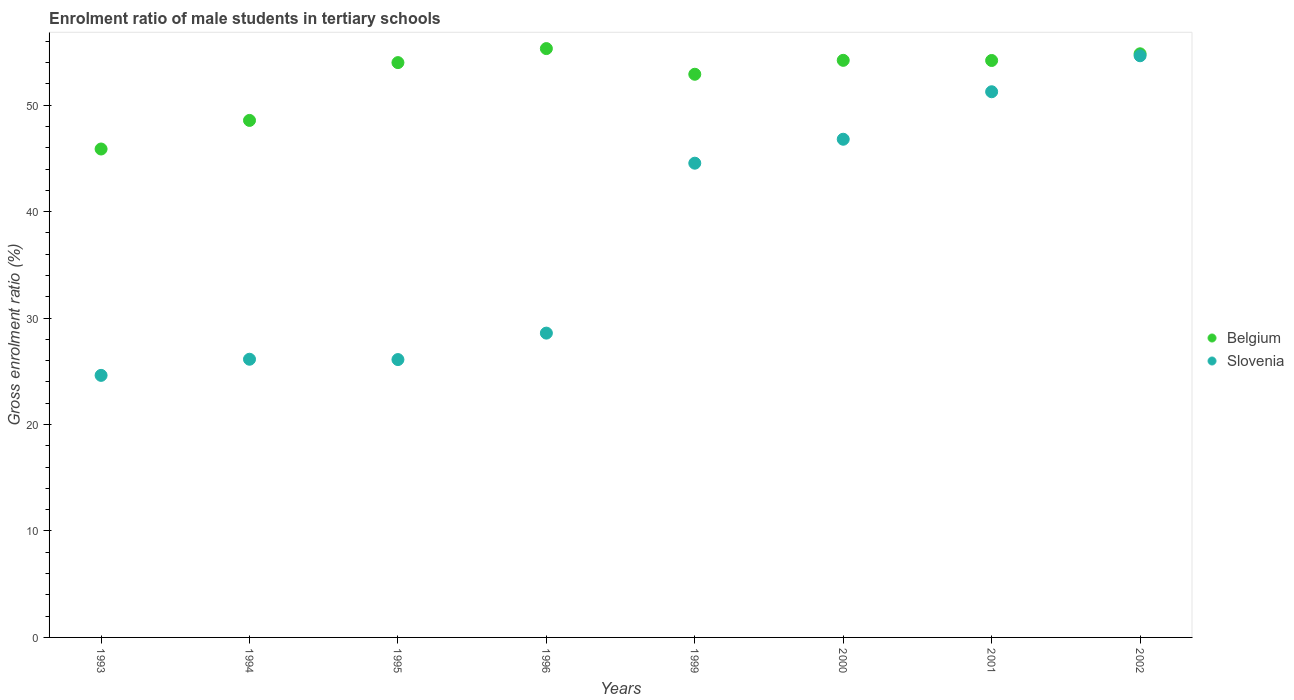Is the number of dotlines equal to the number of legend labels?
Offer a very short reply. Yes. What is the enrolment ratio of male students in tertiary schools in Slovenia in 2002?
Your answer should be compact. 54.65. Across all years, what is the maximum enrolment ratio of male students in tertiary schools in Belgium?
Ensure brevity in your answer.  55.33. Across all years, what is the minimum enrolment ratio of male students in tertiary schools in Belgium?
Offer a terse response. 45.89. What is the total enrolment ratio of male students in tertiary schools in Belgium in the graph?
Provide a short and direct response. 419.98. What is the difference between the enrolment ratio of male students in tertiary schools in Slovenia in 1994 and that in 2000?
Ensure brevity in your answer.  -20.67. What is the difference between the enrolment ratio of male students in tertiary schools in Belgium in 1994 and the enrolment ratio of male students in tertiary schools in Slovenia in 1999?
Make the answer very short. 4.02. What is the average enrolment ratio of male students in tertiary schools in Belgium per year?
Offer a very short reply. 52.5. In the year 1993, what is the difference between the enrolment ratio of male students in tertiary schools in Slovenia and enrolment ratio of male students in tertiary schools in Belgium?
Provide a succinct answer. -21.27. What is the ratio of the enrolment ratio of male students in tertiary schools in Belgium in 1996 to that in 2002?
Ensure brevity in your answer.  1.01. What is the difference between the highest and the second highest enrolment ratio of male students in tertiary schools in Belgium?
Make the answer very short. 0.49. What is the difference between the highest and the lowest enrolment ratio of male students in tertiary schools in Belgium?
Your answer should be compact. 9.44. In how many years, is the enrolment ratio of male students in tertiary schools in Belgium greater than the average enrolment ratio of male students in tertiary schools in Belgium taken over all years?
Offer a terse response. 6. Is the sum of the enrolment ratio of male students in tertiary schools in Slovenia in 1993 and 1994 greater than the maximum enrolment ratio of male students in tertiary schools in Belgium across all years?
Your answer should be very brief. No. Does the enrolment ratio of male students in tertiary schools in Slovenia monotonically increase over the years?
Keep it short and to the point. No. Is the enrolment ratio of male students in tertiary schools in Belgium strictly less than the enrolment ratio of male students in tertiary schools in Slovenia over the years?
Your answer should be very brief. No. How many years are there in the graph?
Make the answer very short. 8. What is the difference between two consecutive major ticks on the Y-axis?
Offer a terse response. 10. Does the graph contain grids?
Offer a very short reply. No. What is the title of the graph?
Offer a very short reply. Enrolment ratio of male students in tertiary schools. What is the label or title of the X-axis?
Ensure brevity in your answer.  Years. What is the Gross enrolment ratio (%) of Belgium in 1993?
Your response must be concise. 45.89. What is the Gross enrolment ratio (%) in Slovenia in 1993?
Give a very brief answer. 24.62. What is the Gross enrolment ratio (%) of Belgium in 1994?
Provide a succinct answer. 48.58. What is the Gross enrolment ratio (%) in Slovenia in 1994?
Your answer should be very brief. 26.14. What is the Gross enrolment ratio (%) of Belgium in 1995?
Your answer should be compact. 54.01. What is the Gross enrolment ratio (%) of Slovenia in 1995?
Keep it short and to the point. 26.11. What is the Gross enrolment ratio (%) in Belgium in 1996?
Provide a succinct answer. 55.33. What is the Gross enrolment ratio (%) in Slovenia in 1996?
Offer a terse response. 28.59. What is the Gross enrolment ratio (%) in Belgium in 1999?
Provide a succinct answer. 52.91. What is the Gross enrolment ratio (%) in Slovenia in 1999?
Ensure brevity in your answer.  44.56. What is the Gross enrolment ratio (%) of Belgium in 2000?
Provide a short and direct response. 54.22. What is the Gross enrolment ratio (%) of Slovenia in 2000?
Keep it short and to the point. 46.81. What is the Gross enrolment ratio (%) in Belgium in 2001?
Offer a very short reply. 54.21. What is the Gross enrolment ratio (%) in Slovenia in 2001?
Provide a short and direct response. 51.27. What is the Gross enrolment ratio (%) in Belgium in 2002?
Keep it short and to the point. 54.84. What is the Gross enrolment ratio (%) in Slovenia in 2002?
Provide a short and direct response. 54.65. Across all years, what is the maximum Gross enrolment ratio (%) in Belgium?
Provide a succinct answer. 55.33. Across all years, what is the maximum Gross enrolment ratio (%) in Slovenia?
Offer a very short reply. 54.65. Across all years, what is the minimum Gross enrolment ratio (%) of Belgium?
Offer a very short reply. 45.89. Across all years, what is the minimum Gross enrolment ratio (%) of Slovenia?
Offer a very short reply. 24.62. What is the total Gross enrolment ratio (%) in Belgium in the graph?
Provide a short and direct response. 419.98. What is the total Gross enrolment ratio (%) in Slovenia in the graph?
Provide a short and direct response. 302.75. What is the difference between the Gross enrolment ratio (%) in Belgium in 1993 and that in 1994?
Offer a very short reply. -2.69. What is the difference between the Gross enrolment ratio (%) in Slovenia in 1993 and that in 1994?
Provide a succinct answer. -1.52. What is the difference between the Gross enrolment ratio (%) in Belgium in 1993 and that in 1995?
Provide a succinct answer. -8.12. What is the difference between the Gross enrolment ratio (%) in Slovenia in 1993 and that in 1995?
Provide a short and direct response. -1.49. What is the difference between the Gross enrolment ratio (%) of Belgium in 1993 and that in 1996?
Your answer should be compact. -9.44. What is the difference between the Gross enrolment ratio (%) of Slovenia in 1993 and that in 1996?
Offer a terse response. -3.97. What is the difference between the Gross enrolment ratio (%) in Belgium in 1993 and that in 1999?
Your answer should be very brief. -7.02. What is the difference between the Gross enrolment ratio (%) in Slovenia in 1993 and that in 1999?
Offer a very short reply. -19.94. What is the difference between the Gross enrolment ratio (%) in Belgium in 1993 and that in 2000?
Offer a terse response. -8.33. What is the difference between the Gross enrolment ratio (%) in Slovenia in 1993 and that in 2000?
Ensure brevity in your answer.  -22.19. What is the difference between the Gross enrolment ratio (%) of Belgium in 1993 and that in 2001?
Provide a succinct answer. -8.32. What is the difference between the Gross enrolment ratio (%) of Slovenia in 1993 and that in 2001?
Your answer should be compact. -26.65. What is the difference between the Gross enrolment ratio (%) of Belgium in 1993 and that in 2002?
Give a very brief answer. -8.95. What is the difference between the Gross enrolment ratio (%) in Slovenia in 1993 and that in 2002?
Offer a very short reply. -30.03. What is the difference between the Gross enrolment ratio (%) of Belgium in 1994 and that in 1995?
Make the answer very short. -5.43. What is the difference between the Gross enrolment ratio (%) in Slovenia in 1994 and that in 1995?
Keep it short and to the point. 0.03. What is the difference between the Gross enrolment ratio (%) in Belgium in 1994 and that in 1996?
Offer a terse response. -6.75. What is the difference between the Gross enrolment ratio (%) in Slovenia in 1994 and that in 1996?
Your answer should be compact. -2.45. What is the difference between the Gross enrolment ratio (%) in Belgium in 1994 and that in 1999?
Give a very brief answer. -4.34. What is the difference between the Gross enrolment ratio (%) in Slovenia in 1994 and that in 1999?
Provide a short and direct response. -18.42. What is the difference between the Gross enrolment ratio (%) of Belgium in 1994 and that in 2000?
Your answer should be compact. -5.64. What is the difference between the Gross enrolment ratio (%) in Slovenia in 1994 and that in 2000?
Give a very brief answer. -20.67. What is the difference between the Gross enrolment ratio (%) of Belgium in 1994 and that in 2001?
Provide a short and direct response. -5.63. What is the difference between the Gross enrolment ratio (%) of Slovenia in 1994 and that in 2001?
Keep it short and to the point. -25.13. What is the difference between the Gross enrolment ratio (%) in Belgium in 1994 and that in 2002?
Keep it short and to the point. -6.26. What is the difference between the Gross enrolment ratio (%) of Slovenia in 1994 and that in 2002?
Give a very brief answer. -28.52. What is the difference between the Gross enrolment ratio (%) of Belgium in 1995 and that in 1996?
Your answer should be very brief. -1.32. What is the difference between the Gross enrolment ratio (%) of Slovenia in 1995 and that in 1996?
Ensure brevity in your answer.  -2.49. What is the difference between the Gross enrolment ratio (%) of Belgium in 1995 and that in 1999?
Offer a terse response. 1.09. What is the difference between the Gross enrolment ratio (%) of Slovenia in 1995 and that in 1999?
Offer a very short reply. -18.45. What is the difference between the Gross enrolment ratio (%) in Belgium in 1995 and that in 2000?
Ensure brevity in your answer.  -0.21. What is the difference between the Gross enrolment ratio (%) of Slovenia in 1995 and that in 2000?
Ensure brevity in your answer.  -20.7. What is the difference between the Gross enrolment ratio (%) in Belgium in 1995 and that in 2001?
Give a very brief answer. -0.2. What is the difference between the Gross enrolment ratio (%) in Slovenia in 1995 and that in 2001?
Provide a succinct answer. -25.16. What is the difference between the Gross enrolment ratio (%) of Belgium in 1995 and that in 2002?
Ensure brevity in your answer.  -0.83. What is the difference between the Gross enrolment ratio (%) of Slovenia in 1995 and that in 2002?
Your answer should be compact. -28.55. What is the difference between the Gross enrolment ratio (%) of Belgium in 1996 and that in 1999?
Give a very brief answer. 2.41. What is the difference between the Gross enrolment ratio (%) of Slovenia in 1996 and that in 1999?
Keep it short and to the point. -15.97. What is the difference between the Gross enrolment ratio (%) in Belgium in 1996 and that in 2000?
Provide a succinct answer. 1.1. What is the difference between the Gross enrolment ratio (%) of Slovenia in 1996 and that in 2000?
Your answer should be compact. -18.22. What is the difference between the Gross enrolment ratio (%) of Belgium in 1996 and that in 2001?
Your response must be concise. 1.12. What is the difference between the Gross enrolment ratio (%) in Slovenia in 1996 and that in 2001?
Give a very brief answer. -22.68. What is the difference between the Gross enrolment ratio (%) in Belgium in 1996 and that in 2002?
Offer a terse response. 0.49. What is the difference between the Gross enrolment ratio (%) of Slovenia in 1996 and that in 2002?
Your response must be concise. -26.06. What is the difference between the Gross enrolment ratio (%) of Belgium in 1999 and that in 2000?
Offer a terse response. -1.31. What is the difference between the Gross enrolment ratio (%) in Slovenia in 1999 and that in 2000?
Your answer should be compact. -2.25. What is the difference between the Gross enrolment ratio (%) of Belgium in 1999 and that in 2001?
Provide a succinct answer. -1.29. What is the difference between the Gross enrolment ratio (%) in Slovenia in 1999 and that in 2001?
Give a very brief answer. -6.71. What is the difference between the Gross enrolment ratio (%) of Belgium in 1999 and that in 2002?
Offer a very short reply. -1.92. What is the difference between the Gross enrolment ratio (%) in Slovenia in 1999 and that in 2002?
Offer a terse response. -10.09. What is the difference between the Gross enrolment ratio (%) of Belgium in 2000 and that in 2001?
Keep it short and to the point. 0.01. What is the difference between the Gross enrolment ratio (%) in Slovenia in 2000 and that in 2001?
Make the answer very short. -4.46. What is the difference between the Gross enrolment ratio (%) of Belgium in 2000 and that in 2002?
Make the answer very short. -0.61. What is the difference between the Gross enrolment ratio (%) in Slovenia in 2000 and that in 2002?
Offer a terse response. -7.84. What is the difference between the Gross enrolment ratio (%) of Belgium in 2001 and that in 2002?
Your response must be concise. -0.63. What is the difference between the Gross enrolment ratio (%) in Slovenia in 2001 and that in 2002?
Keep it short and to the point. -3.38. What is the difference between the Gross enrolment ratio (%) in Belgium in 1993 and the Gross enrolment ratio (%) in Slovenia in 1994?
Keep it short and to the point. 19.75. What is the difference between the Gross enrolment ratio (%) of Belgium in 1993 and the Gross enrolment ratio (%) of Slovenia in 1995?
Offer a terse response. 19.78. What is the difference between the Gross enrolment ratio (%) in Belgium in 1993 and the Gross enrolment ratio (%) in Slovenia in 1996?
Give a very brief answer. 17.3. What is the difference between the Gross enrolment ratio (%) of Belgium in 1993 and the Gross enrolment ratio (%) of Slovenia in 1999?
Provide a short and direct response. 1.33. What is the difference between the Gross enrolment ratio (%) in Belgium in 1993 and the Gross enrolment ratio (%) in Slovenia in 2000?
Offer a very short reply. -0.92. What is the difference between the Gross enrolment ratio (%) of Belgium in 1993 and the Gross enrolment ratio (%) of Slovenia in 2001?
Provide a succinct answer. -5.38. What is the difference between the Gross enrolment ratio (%) in Belgium in 1993 and the Gross enrolment ratio (%) in Slovenia in 2002?
Offer a terse response. -8.76. What is the difference between the Gross enrolment ratio (%) in Belgium in 1994 and the Gross enrolment ratio (%) in Slovenia in 1995?
Give a very brief answer. 22.47. What is the difference between the Gross enrolment ratio (%) in Belgium in 1994 and the Gross enrolment ratio (%) in Slovenia in 1996?
Your response must be concise. 19.99. What is the difference between the Gross enrolment ratio (%) in Belgium in 1994 and the Gross enrolment ratio (%) in Slovenia in 1999?
Provide a short and direct response. 4.02. What is the difference between the Gross enrolment ratio (%) in Belgium in 1994 and the Gross enrolment ratio (%) in Slovenia in 2000?
Ensure brevity in your answer.  1.77. What is the difference between the Gross enrolment ratio (%) in Belgium in 1994 and the Gross enrolment ratio (%) in Slovenia in 2001?
Offer a terse response. -2.69. What is the difference between the Gross enrolment ratio (%) in Belgium in 1994 and the Gross enrolment ratio (%) in Slovenia in 2002?
Offer a terse response. -6.07. What is the difference between the Gross enrolment ratio (%) in Belgium in 1995 and the Gross enrolment ratio (%) in Slovenia in 1996?
Make the answer very short. 25.42. What is the difference between the Gross enrolment ratio (%) of Belgium in 1995 and the Gross enrolment ratio (%) of Slovenia in 1999?
Keep it short and to the point. 9.45. What is the difference between the Gross enrolment ratio (%) in Belgium in 1995 and the Gross enrolment ratio (%) in Slovenia in 2000?
Offer a very short reply. 7.2. What is the difference between the Gross enrolment ratio (%) of Belgium in 1995 and the Gross enrolment ratio (%) of Slovenia in 2001?
Make the answer very short. 2.74. What is the difference between the Gross enrolment ratio (%) of Belgium in 1995 and the Gross enrolment ratio (%) of Slovenia in 2002?
Offer a very short reply. -0.64. What is the difference between the Gross enrolment ratio (%) in Belgium in 1996 and the Gross enrolment ratio (%) in Slovenia in 1999?
Your answer should be compact. 10.77. What is the difference between the Gross enrolment ratio (%) of Belgium in 1996 and the Gross enrolment ratio (%) of Slovenia in 2000?
Give a very brief answer. 8.52. What is the difference between the Gross enrolment ratio (%) in Belgium in 1996 and the Gross enrolment ratio (%) in Slovenia in 2001?
Give a very brief answer. 4.06. What is the difference between the Gross enrolment ratio (%) in Belgium in 1996 and the Gross enrolment ratio (%) in Slovenia in 2002?
Your response must be concise. 0.67. What is the difference between the Gross enrolment ratio (%) in Belgium in 1999 and the Gross enrolment ratio (%) in Slovenia in 2000?
Keep it short and to the point. 6.11. What is the difference between the Gross enrolment ratio (%) of Belgium in 1999 and the Gross enrolment ratio (%) of Slovenia in 2001?
Your answer should be compact. 1.64. What is the difference between the Gross enrolment ratio (%) of Belgium in 1999 and the Gross enrolment ratio (%) of Slovenia in 2002?
Your answer should be very brief. -1.74. What is the difference between the Gross enrolment ratio (%) in Belgium in 2000 and the Gross enrolment ratio (%) in Slovenia in 2001?
Make the answer very short. 2.95. What is the difference between the Gross enrolment ratio (%) in Belgium in 2000 and the Gross enrolment ratio (%) in Slovenia in 2002?
Offer a very short reply. -0.43. What is the difference between the Gross enrolment ratio (%) of Belgium in 2001 and the Gross enrolment ratio (%) of Slovenia in 2002?
Offer a terse response. -0.44. What is the average Gross enrolment ratio (%) of Belgium per year?
Your answer should be compact. 52.5. What is the average Gross enrolment ratio (%) in Slovenia per year?
Keep it short and to the point. 37.84. In the year 1993, what is the difference between the Gross enrolment ratio (%) in Belgium and Gross enrolment ratio (%) in Slovenia?
Keep it short and to the point. 21.27. In the year 1994, what is the difference between the Gross enrolment ratio (%) in Belgium and Gross enrolment ratio (%) in Slovenia?
Give a very brief answer. 22.44. In the year 1995, what is the difference between the Gross enrolment ratio (%) of Belgium and Gross enrolment ratio (%) of Slovenia?
Make the answer very short. 27.9. In the year 1996, what is the difference between the Gross enrolment ratio (%) in Belgium and Gross enrolment ratio (%) in Slovenia?
Keep it short and to the point. 26.73. In the year 1999, what is the difference between the Gross enrolment ratio (%) of Belgium and Gross enrolment ratio (%) of Slovenia?
Offer a terse response. 8.36. In the year 2000, what is the difference between the Gross enrolment ratio (%) in Belgium and Gross enrolment ratio (%) in Slovenia?
Offer a very short reply. 7.41. In the year 2001, what is the difference between the Gross enrolment ratio (%) of Belgium and Gross enrolment ratio (%) of Slovenia?
Offer a terse response. 2.94. In the year 2002, what is the difference between the Gross enrolment ratio (%) of Belgium and Gross enrolment ratio (%) of Slovenia?
Offer a very short reply. 0.18. What is the ratio of the Gross enrolment ratio (%) of Belgium in 1993 to that in 1994?
Offer a terse response. 0.94. What is the ratio of the Gross enrolment ratio (%) of Slovenia in 1993 to that in 1994?
Make the answer very short. 0.94. What is the ratio of the Gross enrolment ratio (%) in Belgium in 1993 to that in 1995?
Your answer should be compact. 0.85. What is the ratio of the Gross enrolment ratio (%) of Slovenia in 1993 to that in 1995?
Provide a short and direct response. 0.94. What is the ratio of the Gross enrolment ratio (%) in Belgium in 1993 to that in 1996?
Ensure brevity in your answer.  0.83. What is the ratio of the Gross enrolment ratio (%) in Slovenia in 1993 to that in 1996?
Your answer should be very brief. 0.86. What is the ratio of the Gross enrolment ratio (%) in Belgium in 1993 to that in 1999?
Your answer should be compact. 0.87. What is the ratio of the Gross enrolment ratio (%) in Slovenia in 1993 to that in 1999?
Offer a terse response. 0.55. What is the ratio of the Gross enrolment ratio (%) in Belgium in 1993 to that in 2000?
Keep it short and to the point. 0.85. What is the ratio of the Gross enrolment ratio (%) of Slovenia in 1993 to that in 2000?
Your answer should be very brief. 0.53. What is the ratio of the Gross enrolment ratio (%) in Belgium in 1993 to that in 2001?
Ensure brevity in your answer.  0.85. What is the ratio of the Gross enrolment ratio (%) of Slovenia in 1993 to that in 2001?
Make the answer very short. 0.48. What is the ratio of the Gross enrolment ratio (%) of Belgium in 1993 to that in 2002?
Your answer should be very brief. 0.84. What is the ratio of the Gross enrolment ratio (%) in Slovenia in 1993 to that in 2002?
Provide a succinct answer. 0.45. What is the ratio of the Gross enrolment ratio (%) of Belgium in 1994 to that in 1995?
Your response must be concise. 0.9. What is the ratio of the Gross enrolment ratio (%) of Belgium in 1994 to that in 1996?
Offer a very short reply. 0.88. What is the ratio of the Gross enrolment ratio (%) in Slovenia in 1994 to that in 1996?
Provide a succinct answer. 0.91. What is the ratio of the Gross enrolment ratio (%) of Belgium in 1994 to that in 1999?
Keep it short and to the point. 0.92. What is the ratio of the Gross enrolment ratio (%) in Slovenia in 1994 to that in 1999?
Keep it short and to the point. 0.59. What is the ratio of the Gross enrolment ratio (%) of Belgium in 1994 to that in 2000?
Your answer should be very brief. 0.9. What is the ratio of the Gross enrolment ratio (%) in Slovenia in 1994 to that in 2000?
Give a very brief answer. 0.56. What is the ratio of the Gross enrolment ratio (%) in Belgium in 1994 to that in 2001?
Ensure brevity in your answer.  0.9. What is the ratio of the Gross enrolment ratio (%) in Slovenia in 1994 to that in 2001?
Give a very brief answer. 0.51. What is the ratio of the Gross enrolment ratio (%) of Belgium in 1994 to that in 2002?
Your answer should be compact. 0.89. What is the ratio of the Gross enrolment ratio (%) in Slovenia in 1994 to that in 2002?
Keep it short and to the point. 0.48. What is the ratio of the Gross enrolment ratio (%) in Belgium in 1995 to that in 1996?
Provide a short and direct response. 0.98. What is the ratio of the Gross enrolment ratio (%) of Slovenia in 1995 to that in 1996?
Your response must be concise. 0.91. What is the ratio of the Gross enrolment ratio (%) of Belgium in 1995 to that in 1999?
Your answer should be compact. 1.02. What is the ratio of the Gross enrolment ratio (%) in Slovenia in 1995 to that in 1999?
Offer a very short reply. 0.59. What is the ratio of the Gross enrolment ratio (%) in Slovenia in 1995 to that in 2000?
Offer a very short reply. 0.56. What is the ratio of the Gross enrolment ratio (%) in Belgium in 1995 to that in 2001?
Provide a short and direct response. 1. What is the ratio of the Gross enrolment ratio (%) in Slovenia in 1995 to that in 2001?
Make the answer very short. 0.51. What is the ratio of the Gross enrolment ratio (%) in Belgium in 1995 to that in 2002?
Offer a terse response. 0.98. What is the ratio of the Gross enrolment ratio (%) of Slovenia in 1995 to that in 2002?
Provide a succinct answer. 0.48. What is the ratio of the Gross enrolment ratio (%) in Belgium in 1996 to that in 1999?
Provide a short and direct response. 1.05. What is the ratio of the Gross enrolment ratio (%) of Slovenia in 1996 to that in 1999?
Give a very brief answer. 0.64. What is the ratio of the Gross enrolment ratio (%) in Belgium in 1996 to that in 2000?
Ensure brevity in your answer.  1.02. What is the ratio of the Gross enrolment ratio (%) in Slovenia in 1996 to that in 2000?
Offer a very short reply. 0.61. What is the ratio of the Gross enrolment ratio (%) in Belgium in 1996 to that in 2001?
Offer a terse response. 1.02. What is the ratio of the Gross enrolment ratio (%) in Slovenia in 1996 to that in 2001?
Your answer should be compact. 0.56. What is the ratio of the Gross enrolment ratio (%) in Belgium in 1996 to that in 2002?
Give a very brief answer. 1.01. What is the ratio of the Gross enrolment ratio (%) in Slovenia in 1996 to that in 2002?
Ensure brevity in your answer.  0.52. What is the ratio of the Gross enrolment ratio (%) of Belgium in 1999 to that in 2000?
Your answer should be compact. 0.98. What is the ratio of the Gross enrolment ratio (%) of Slovenia in 1999 to that in 2000?
Provide a succinct answer. 0.95. What is the ratio of the Gross enrolment ratio (%) in Belgium in 1999 to that in 2001?
Provide a succinct answer. 0.98. What is the ratio of the Gross enrolment ratio (%) in Slovenia in 1999 to that in 2001?
Provide a succinct answer. 0.87. What is the ratio of the Gross enrolment ratio (%) in Belgium in 1999 to that in 2002?
Ensure brevity in your answer.  0.96. What is the ratio of the Gross enrolment ratio (%) of Slovenia in 1999 to that in 2002?
Give a very brief answer. 0.82. What is the ratio of the Gross enrolment ratio (%) of Slovenia in 2000 to that in 2002?
Provide a succinct answer. 0.86. What is the ratio of the Gross enrolment ratio (%) of Belgium in 2001 to that in 2002?
Ensure brevity in your answer.  0.99. What is the ratio of the Gross enrolment ratio (%) of Slovenia in 2001 to that in 2002?
Offer a terse response. 0.94. What is the difference between the highest and the second highest Gross enrolment ratio (%) of Belgium?
Give a very brief answer. 0.49. What is the difference between the highest and the second highest Gross enrolment ratio (%) of Slovenia?
Your response must be concise. 3.38. What is the difference between the highest and the lowest Gross enrolment ratio (%) of Belgium?
Provide a short and direct response. 9.44. What is the difference between the highest and the lowest Gross enrolment ratio (%) in Slovenia?
Make the answer very short. 30.03. 